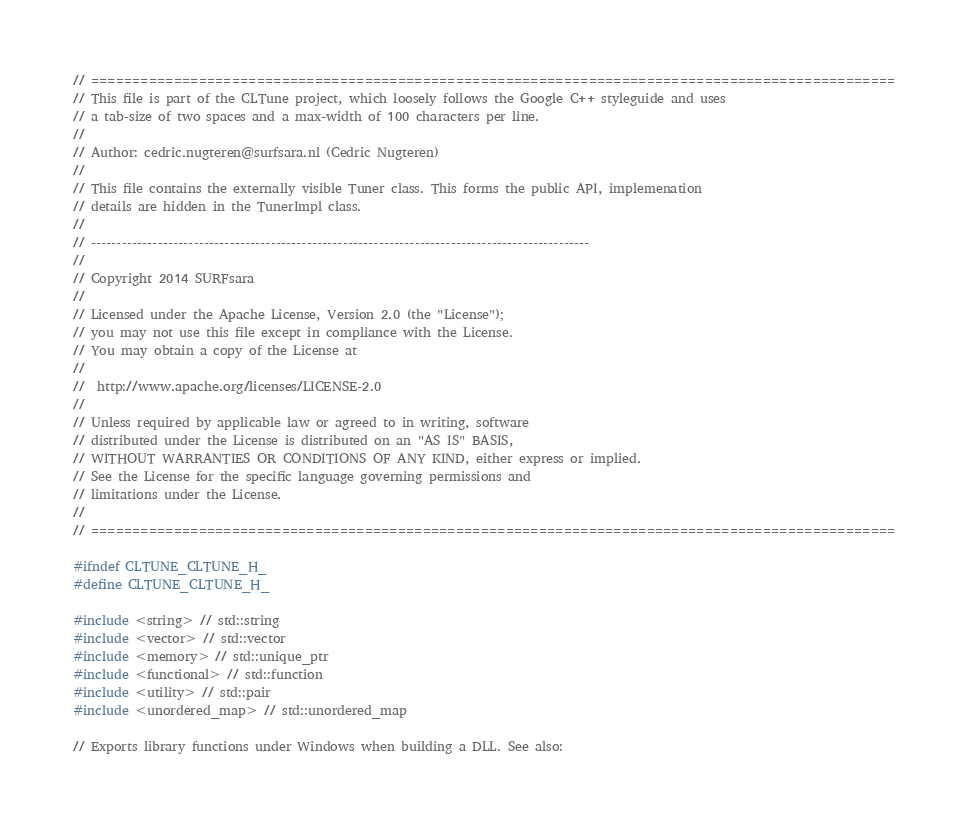<code> <loc_0><loc_0><loc_500><loc_500><_C_>
// =================================================================================================
// This file is part of the CLTune project, which loosely follows the Google C++ styleguide and uses
// a tab-size of two spaces and a max-width of 100 characters per line.
//
// Author: cedric.nugteren@surfsara.nl (Cedric Nugteren)
//
// This file contains the externally visible Tuner class. This forms the public API, implemenation
// details are hidden in the TunerImpl class.
//
// -------------------------------------------------------------------------------------------------
//
// Copyright 2014 SURFsara
// 
// Licensed under the Apache License, Version 2.0 (the "License");
// you may not use this file except in compliance with the License.
// You may obtain a copy of the License at
// 
//  http://www.apache.org/licenses/LICENSE-2.0
// 
// Unless required by applicable law or agreed to in writing, software
// distributed under the License is distributed on an "AS IS" BASIS,
// WITHOUT WARRANTIES OR CONDITIONS OF ANY KIND, either express or implied.
// See the License for the specific language governing permissions and
// limitations under the License.
//
// =================================================================================================

#ifndef CLTUNE_CLTUNE_H_
#define CLTUNE_CLTUNE_H_

#include <string> // std::string
#include <vector> // std::vector
#include <memory> // std::unique_ptr
#include <functional> // std::function
#include <utility> // std::pair
#include <unordered_map> // std::unordered_map

// Exports library functions under Windows when building a DLL. See also:</code> 